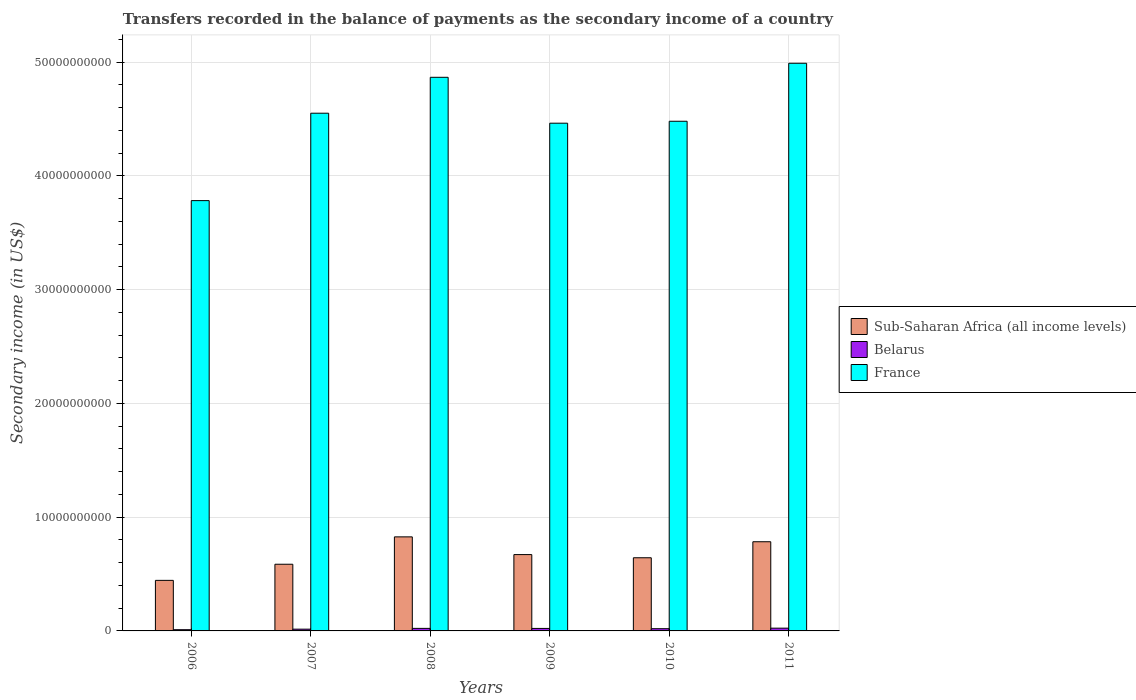How many different coloured bars are there?
Ensure brevity in your answer.  3. Are the number of bars per tick equal to the number of legend labels?
Provide a succinct answer. Yes. Are the number of bars on each tick of the X-axis equal?
Provide a succinct answer. Yes. How many bars are there on the 4th tick from the left?
Ensure brevity in your answer.  3. How many bars are there on the 4th tick from the right?
Give a very brief answer. 3. In how many cases, is the number of bars for a given year not equal to the number of legend labels?
Your answer should be compact. 0. What is the secondary income of in France in 2006?
Keep it short and to the point. 3.78e+1. Across all years, what is the maximum secondary income of in France?
Your answer should be very brief. 4.99e+1. Across all years, what is the minimum secondary income of in France?
Offer a terse response. 3.78e+1. In which year was the secondary income of in Belarus maximum?
Offer a very short reply. 2011. In which year was the secondary income of in Belarus minimum?
Give a very brief answer. 2006. What is the total secondary income of in Belarus in the graph?
Your response must be concise. 1.14e+09. What is the difference between the secondary income of in Belarus in 2007 and that in 2010?
Your response must be concise. -4.09e+07. What is the difference between the secondary income of in Sub-Saharan Africa (all income levels) in 2008 and the secondary income of in France in 2009?
Provide a succinct answer. -3.64e+1. What is the average secondary income of in Sub-Saharan Africa (all income levels) per year?
Your answer should be compact. 6.59e+09. In the year 2009, what is the difference between the secondary income of in France and secondary income of in Sub-Saharan Africa (all income levels)?
Your response must be concise. 3.79e+1. What is the ratio of the secondary income of in Belarus in 2006 to that in 2011?
Your answer should be compact. 0.45. Is the difference between the secondary income of in France in 2006 and 2011 greater than the difference between the secondary income of in Sub-Saharan Africa (all income levels) in 2006 and 2011?
Your answer should be compact. No. What is the difference between the highest and the second highest secondary income of in Sub-Saharan Africa (all income levels)?
Your answer should be very brief. 4.28e+08. What is the difference between the highest and the lowest secondary income of in Belarus?
Provide a short and direct response. 1.35e+08. In how many years, is the secondary income of in France greater than the average secondary income of in France taken over all years?
Keep it short and to the point. 3. Is the sum of the secondary income of in France in 2009 and 2010 greater than the maximum secondary income of in Sub-Saharan Africa (all income levels) across all years?
Give a very brief answer. Yes. What does the 3rd bar from the left in 2006 represents?
Make the answer very short. France. What does the 3rd bar from the right in 2011 represents?
Provide a succinct answer. Sub-Saharan Africa (all income levels). Is it the case that in every year, the sum of the secondary income of in France and secondary income of in Belarus is greater than the secondary income of in Sub-Saharan Africa (all income levels)?
Offer a terse response. Yes. Are all the bars in the graph horizontal?
Provide a short and direct response. No. How many years are there in the graph?
Offer a very short reply. 6. What is the difference between two consecutive major ticks on the Y-axis?
Make the answer very short. 1.00e+1. Are the values on the major ticks of Y-axis written in scientific E-notation?
Keep it short and to the point. No. Does the graph contain grids?
Your answer should be very brief. Yes. How are the legend labels stacked?
Your answer should be very brief. Vertical. What is the title of the graph?
Provide a short and direct response. Transfers recorded in the balance of payments as the secondary income of a country. What is the label or title of the Y-axis?
Give a very brief answer. Secondary income (in US$). What is the Secondary income (in US$) in Sub-Saharan Africa (all income levels) in 2006?
Offer a terse response. 4.45e+09. What is the Secondary income (in US$) in Belarus in 2006?
Ensure brevity in your answer.  1.08e+08. What is the Secondary income (in US$) of France in 2006?
Give a very brief answer. 3.78e+1. What is the Secondary income (in US$) of Sub-Saharan Africa (all income levels) in 2007?
Give a very brief answer. 5.86e+09. What is the Secondary income (in US$) of Belarus in 2007?
Keep it short and to the point. 1.55e+08. What is the Secondary income (in US$) in France in 2007?
Make the answer very short. 4.55e+1. What is the Secondary income (in US$) in Sub-Saharan Africa (all income levels) in 2008?
Provide a short and direct response. 8.27e+09. What is the Secondary income (in US$) of Belarus in 2008?
Make the answer very short. 2.23e+08. What is the Secondary income (in US$) of France in 2008?
Offer a very short reply. 4.87e+1. What is the Secondary income (in US$) of Sub-Saharan Africa (all income levels) in 2009?
Keep it short and to the point. 6.71e+09. What is the Secondary income (in US$) in Belarus in 2009?
Your answer should be compact. 2.20e+08. What is the Secondary income (in US$) of France in 2009?
Keep it short and to the point. 4.46e+1. What is the Secondary income (in US$) of Sub-Saharan Africa (all income levels) in 2010?
Your response must be concise. 6.43e+09. What is the Secondary income (in US$) in Belarus in 2010?
Offer a terse response. 1.96e+08. What is the Secondary income (in US$) of France in 2010?
Keep it short and to the point. 4.48e+1. What is the Secondary income (in US$) of Sub-Saharan Africa (all income levels) in 2011?
Offer a very short reply. 7.84e+09. What is the Secondary income (in US$) of Belarus in 2011?
Make the answer very short. 2.43e+08. What is the Secondary income (in US$) of France in 2011?
Your answer should be very brief. 4.99e+1. Across all years, what is the maximum Secondary income (in US$) of Sub-Saharan Africa (all income levels)?
Keep it short and to the point. 8.27e+09. Across all years, what is the maximum Secondary income (in US$) of Belarus?
Your response must be concise. 2.43e+08. Across all years, what is the maximum Secondary income (in US$) of France?
Your answer should be compact. 4.99e+1. Across all years, what is the minimum Secondary income (in US$) in Sub-Saharan Africa (all income levels)?
Provide a succinct answer. 4.45e+09. Across all years, what is the minimum Secondary income (in US$) of Belarus?
Your response must be concise. 1.08e+08. Across all years, what is the minimum Secondary income (in US$) in France?
Offer a terse response. 3.78e+1. What is the total Secondary income (in US$) in Sub-Saharan Africa (all income levels) in the graph?
Your answer should be very brief. 3.96e+1. What is the total Secondary income (in US$) in Belarus in the graph?
Keep it short and to the point. 1.14e+09. What is the total Secondary income (in US$) of France in the graph?
Keep it short and to the point. 2.71e+11. What is the difference between the Secondary income (in US$) of Sub-Saharan Africa (all income levels) in 2006 and that in 2007?
Offer a very short reply. -1.42e+09. What is the difference between the Secondary income (in US$) of Belarus in 2006 and that in 2007?
Give a very brief answer. -4.69e+07. What is the difference between the Secondary income (in US$) in France in 2006 and that in 2007?
Give a very brief answer. -7.69e+09. What is the difference between the Secondary income (in US$) in Sub-Saharan Africa (all income levels) in 2006 and that in 2008?
Provide a succinct answer. -3.82e+09. What is the difference between the Secondary income (in US$) of Belarus in 2006 and that in 2008?
Give a very brief answer. -1.14e+08. What is the difference between the Secondary income (in US$) in France in 2006 and that in 2008?
Offer a terse response. -1.08e+1. What is the difference between the Secondary income (in US$) in Sub-Saharan Africa (all income levels) in 2006 and that in 2009?
Offer a terse response. -2.27e+09. What is the difference between the Secondary income (in US$) of Belarus in 2006 and that in 2009?
Provide a succinct answer. -1.12e+08. What is the difference between the Secondary income (in US$) in France in 2006 and that in 2009?
Give a very brief answer. -6.81e+09. What is the difference between the Secondary income (in US$) in Sub-Saharan Africa (all income levels) in 2006 and that in 2010?
Make the answer very short. -1.99e+09. What is the difference between the Secondary income (in US$) of Belarus in 2006 and that in 2010?
Give a very brief answer. -8.78e+07. What is the difference between the Secondary income (in US$) of France in 2006 and that in 2010?
Give a very brief answer. -6.98e+09. What is the difference between the Secondary income (in US$) of Sub-Saharan Africa (all income levels) in 2006 and that in 2011?
Make the answer very short. -3.40e+09. What is the difference between the Secondary income (in US$) of Belarus in 2006 and that in 2011?
Make the answer very short. -1.35e+08. What is the difference between the Secondary income (in US$) in France in 2006 and that in 2011?
Keep it short and to the point. -1.21e+1. What is the difference between the Secondary income (in US$) of Sub-Saharan Africa (all income levels) in 2007 and that in 2008?
Give a very brief answer. -2.41e+09. What is the difference between the Secondary income (in US$) of Belarus in 2007 and that in 2008?
Offer a very short reply. -6.76e+07. What is the difference between the Secondary income (in US$) in France in 2007 and that in 2008?
Make the answer very short. -3.16e+09. What is the difference between the Secondary income (in US$) in Sub-Saharan Africa (all income levels) in 2007 and that in 2009?
Offer a very short reply. -8.49e+08. What is the difference between the Secondary income (in US$) of Belarus in 2007 and that in 2009?
Make the answer very short. -6.47e+07. What is the difference between the Secondary income (in US$) in France in 2007 and that in 2009?
Provide a succinct answer. 8.78e+08. What is the difference between the Secondary income (in US$) of Sub-Saharan Africa (all income levels) in 2007 and that in 2010?
Provide a short and direct response. -5.71e+08. What is the difference between the Secondary income (in US$) of Belarus in 2007 and that in 2010?
Give a very brief answer. -4.09e+07. What is the difference between the Secondary income (in US$) in France in 2007 and that in 2010?
Your answer should be very brief. 7.08e+08. What is the difference between the Secondary income (in US$) in Sub-Saharan Africa (all income levels) in 2007 and that in 2011?
Offer a terse response. -1.98e+09. What is the difference between the Secondary income (in US$) in Belarus in 2007 and that in 2011?
Give a very brief answer. -8.79e+07. What is the difference between the Secondary income (in US$) of France in 2007 and that in 2011?
Your answer should be compact. -4.39e+09. What is the difference between the Secondary income (in US$) of Sub-Saharan Africa (all income levels) in 2008 and that in 2009?
Your answer should be compact. 1.56e+09. What is the difference between the Secondary income (in US$) of Belarus in 2008 and that in 2009?
Your response must be concise. 2.90e+06. What is the difference between the Secondary income (in US$) in France in 2008 and that in 2009?
Provide a short and direct response. 4.04e+09. What is the difference between the Secondary income (in US$) in Sub-Saharan Africa (all income levels) in 2008 and that in 2010?
Provide a succinct answer. 1.84e+09. What is the difference between the Secondary income (in US$) in Belarus in 2008 and that in 2010?
Offer a very short reply. 2.67e+07. What is the difference between the Secondary income (in US$) in France in 2008 and that in 2010?
Your response must be concise. 3.86e+09. What is the difference between the Secondary income (in US$) of Sub-Saharan Africa (all income levels) in 2008 and that in 2011?
Make the answer very short. 4.28e+08. What is the difference between the Secondary income (in US$) in Belarus in 2008 and that in 2011?
Your response must be concise. -2.03e+07. What is the difference between the Secondary income (in US$) of France in 2008 and that in 2011?
Your answer should be compact. -1.23e+09. What is the difference between the Secondary income (in US$) in Sub-Saharan Africa (all income levels) in 2009 and that in 2010?
Make the answer very short. 2.78e+08. What is the difference between the Secondary income (in US$) of Belarus in 2009 and that in 2010?
Give a very brief answer. 2.38e+07. What is the difference between the Secondary income (in US$) of France in 2009 and that in 2010?
Keep it short and to the point. -1.71e+08. What is the difference between the Secondary income (in US$) in Sub-Saharan Africa (all income levels) in 2009 and that in 2011?
Make the answer very short. -1.13e+09. What is the difference between the Secondary income (in US$) in Belarus in 2009 and that in 2011?
Make the answer very short. -2.32e+07. What is the difference between the Secondary income (in US$) of France in 2009 and that in 2011?
Ensure brevity in your answer.  -5.27e+09. What is the difference between the Secondary income (in US$) in Sub-Saharan Africa (all income levels) in 2010 and that in 2011?
Provide a short and direct response. -1.41e+09. What is the difference between the Secondary income (in US$) of Belarus in 2010 and that in 2011?
Your answer should be very brief. -4.70e+07. What is the difference between the Secondary income (in US$) in France in 2010 and that in 2011?
Your response must be concise. -5.10e+09. What is the difference between the Secondary income (in US$) in Sub-Saharan Africa (all income levels) in 2006 and the Secondary income (in US$) in Belarus in 2007?
Provide a succinct answer. 4.29e+09. What is the difference between the Secondary income (in US$) in Sub-Saharan Africa (all income levels) in 2006 and the Secondary income (in US$) in France in 2007?
Your answer should be compact. -4.11e+1. What is the difference between the Secondary income (in US$) in Belarus in 2006 and the Secondary income (in US$) in France in 2007?
Your answer should be compact. -4.54e+1. What is the difference between the Secondary income (in US$) of Sub-Saharan Africa (all income levels) in 2006 and the Secondary income (in US$) of Belarus in 2008?
Offer a terse response. 4.22e+09. What is the difference between the Secondary income (in US$) in Sub-Saharan Africa (all income levels) in 2006 and the Secondary income (in US$) in France in 2008?
Give a very brief answer. -4.42e+1. What is the difference between the Secondary income (in US$) of Belarus in 2006 and the Secondary income (in US$) of France in 2008?
Provide a short and direct response. -4.86e+1. What is the difference between the Secondary income (in US$) of Sub-Saharan Africa (all income levels) in 2006 and the Secondary income (in US$) of Belarus in 2009?
Offer a very short reply. 4.23e+09. What is the difference between the Secondary income (in US$) in Sub-Saharan Africa (all income levels) in 2006 and the Secondary income (in US$) in France in 2009?
Your answer should be compact. -4.02e+1. What is the difference between the Secondary income (in US$) in Belarus in 2006 and the Secondary income (in US$) in France in 2009?
Ensure brevity in your answer.  -4.45e+1. What is the difference between the Secondary income (in US$) of Sub-Saharan Africa (all income levels) in 2006 and the Secondary income (in US$) of Belarus in 2010?
Make the answer very short. 4.25e+09. What is the difference between the Secondary income (in US$) of Sub-Saharan Africa (all income levels) in 2006 and the Secondary income (in US$) of France in 2010?
Your answer should be compact. -4.04e+1. What is the difference between the Secondary income (in US$) of Belarus in 2006 and the Secondary income (in US$) of France in 2010?
Give a very brief answer. -4.47e+1. What is the difference between the Secondary income (in US$) of Sub-Saharan Africa (all income levels) in 2006 and the Secondary income (in US$) of Belarus in 2011?
Offer a terse response. 4.20e+09. What is the difference between the Secondary income (in US$) of Sub-Saharan Africa (all income levels) in 2006 and the Secondary income (in US$) of France in 2011?
Make the answer very short. -4.55e+1. What is the difference between the Secondary income (in US$) in Belarus in 2006 and the Secondary income (in US$) in France in 2011?
Provide a succinct answer. -4.98e+1. What is the difference between the Secondary income (in US$) in Sub-Saharan Africa (all income levels) in 2007 and the Secondary income (in US$) in Belarus in 2008?
Give a very brief answer. 5.64e+09. What is the difference between the Secondary income (in US$) in Sub-Saharan Africa (all income levels) in 2007 and the Secondary income (in US$) in France in 2008?
Provide a short and direct response. -4.28e+1. What is the difference between the Secondary income (in US$) of Belarus in 2007 and the Secondary income (in US$) of France in 2008?
Give a very brief answer. -4.85e+1. What is the difference between the Secondary income (in US$) in Sub-Saharan Africa (all income levels) in 2007 and the Secondary income (in US$) in Belarus in 2009?
Offer a very short reply. 5.64e+09. What is the difference between the Secondary income (in US$) of Sub-Saharan Africa (all income levels) in 2007 and the Secondary income (in US$) of France in 2009?
Your answer should be very brief. -3.88e+1. What is the difference between the Secondary income (in US$) of Belarus in 2007 and the Secondary income (in US$) of France in 2009?
Offer a terse response. -4.45e+1. What is the difference between the Secondary income (in US$) of Sub-Saharan Africa (all income levels) in 2007 and the Secondary income (in US$) of Belarus in 2010?
Your response must be concise. 5.67e+09. What is the difference between the Secondary income (in US$) in Sub-Saharan Africa (all income levels) in 2007 and the Secondary income (in US$) in France in 2010?
Provide a succinct answer. -3.89e+1. What is the difference between the Secondary income (in US$) of Belarus in 2007 and the Secondary income (in US$) of France in 2010?
Provide a short and direct response. -4.47e+1. What is the difference between the Secondary income (in US$) of Sub-Saharan Africa (all income levels) in 2007 and the Secondary income (in US$) of Belarus in 2011?
Offer a very short reply. 5.62e+09. What is the difference between the Secondary income (in US$) of Sub-Saharan Africa (all income levels) in 2007 and the Secondary income (in US$) of France in 2011?
Ensure brevity in your answer.  -4.40e+1. What is the difference between the Secondary income (in US$) in Belarus in 2007 and the Secondary income (in US$) in France in 2011?
Offer a terse response. -4.98e+1. What is the difference between the Secondary income (in US$) of Sub-Saharan Africa (all income levels) in 2008 and the Secondary income (in US$) of Belarus in 2009?
Your answer should be very brief. 8.05e+09. What is the difference between the Secondary income (in US$) in Sub-Saharan Africa (all income levels) in 2008 and the Secondary income (in US$) in France in 2009?
Your response must be concise. -3.64e+1. What is the difference between the Secondary income (in US$) of Belarus in 2008 and the Secondary income (in US$) of France in 2009?
Offer a terse response. -4.44e+1. What is the difference between the Secondary income (in US$) in Sub-Saharan Africa (all income levels) in 2008 and the Secondary income (in US$) in Belarus in 2010?
Offer a very short reply. 8.07e+09. What is the difference between the Secondary income (in US$) of Sub-Saharan Africa (all income levels) in 2008 and the Secondary income (in US$) of France in 2010?
Provide a succinct answer. -3.65e+1. What is the difference between the Secondary income (in US$) of Belarus in 2008 and the Secondary income (in US$) of France in 2010?
Offer a terse response. -4.46e+1. What is the difference between the Secondary income (in US$) in Sub-Saharan Africa (all income levels) in 2008 and the Secondary income (in US$) in Belarus in 2011?
Provide a succinct answer. 8.03e+09. What is the difference between the Secondary income (in US$) in Sub-Saharan Africa (all income levels) in 2008 and the Secondary income (in US$) in France in 2011?
Give a very brief answer. -4.16e+1. What is the difference between the Secondary income (in US$) of Belarus in 2008 and the Secondary income (in US$) of France in 2011?
Keep it short and to the point. -4.97e+1. What is the difference between the Secondary income (in US$) of Sub-Saharan Africa (all income levels) in 2009 and the Secondary income (in US$) of Belarus in 2010?
Offer a terse response. 6.52e+09. What is the difference between the Secondary income (in US$) in Sub-Saharan Africa (all income levels) in 2009 and the Secondary income (in US$) in France in 2010?
Provide a succinct answer. -3.81e+1. What is the difference between the Secondary income (in US$) of Belarus in 2009 and the Secondary income (in US$) of France in 2010?
Provide a succinct answer. -4.46e+1. What is the difference between the Secondary income (in US$) in Sub-Saharan Africa (all income levels) in 2009 and the Secondary income (in US$) in Belarus in 2011?
Offer a terse response. 6.47e+09. What is the difference between the Secondary income (in US$) in Sub-Saharan Africa (all income levels) in 2009 and the Secondary income (in US$) in France in 2011?
Provide a succinct answer. -4.32e+1. What is the difference between the Secondary income (in US$) in Belarus in 2009 and the Secondary income (in US$) in France in 2011?
Your answer should be compact. -4.97e+1. What is the difference between the Secondary income (in US$) in Sub-Saharan Africa (all income levels) in 2010 and the Secondary income (in US$) in Belarus in 2011?
Your answer should be very brief. 6.19e+09. What is the difference between the Secondary income (in US$) of Sub-Saharan Africa (all income levels) in 2010 and the Secondary income (in US$) of France in 2011?
Offer a terse response. -4.35e+1. What is the difference between the Secondary income (in US$) of Belarus in 2010 and the Secondary income (in US$) of France in 2011?
Your answer should be very brief. -4.97e+1. What is the average Secondary income (in US$) in Sub-Saharan Africa (all income levels) per year?
Your answer should be compact. 6.59e+09. What is the average Secondary income (in US$) of Belarus per year?
Your answer should be compact. 1.91e+08. What is the average Secondary income (in US$) of France per year?
Ensure brevity in your answer.  4.52e+1. In the year 2006, what is the difference between the Secondary income (in US$) in Sub-Saharan Africa (all income levels) and Secondary income (in US$) in Belarus?
Give a very brief answer. 4.34e+09. In the year 2006, what is the difference between the Secondary income (in US$) of Sub-Saharan Africa (all income levels) and Secondary income (in US$) of France?
Your answer should be compact. -3.34e+1. In the year 2006, what is the difference between the Secondary income (in US$) in Belarus and Secondary income (in US$) in France?
Make the answer very short. -3.77e+1. In the year 2007, what is the difference between the Secondary income (in US$) in Sub-Saharan Africa (all income levels) and Secondary income (in US$) in Belarus?
Provide a succinct answer. 5.71e+09. In the year 2007, what is the difference between the Secondary income (in US$) in Sub-Saharan Africa (all income levels) and Secondary income (in US$) in France?
Your response must be concise. -3.97e+1. In the year 2007, what is the difference between the Secondary income (in US$) of Belarus and Secondary income (in US$) of France?
Provide a short and direct response. -4.54e+1. In the year 2008, what is the difference between the Secondary income (in US$) in Sub-Saharan Africa (all income levels) and Secondary income (in US$) in Belarus?
Keep it short and to the point. 8.05e+09. In the year 2008, what is the difference between the Secondary income (in US$) of Sub-Saharan Africa (all income levels) and Secondary income (in US$) of France?
Ensure brevity in your answer.  -4.04e+1. In the year 2008, what is the difference between the Secondary income (in US$) of Belarus and Secondary income (in US$) of France?
Offer a very short reply. -4.85e+1. In the year 2009, what is the difference between the Secondary income (in US$) in Sub-Saharan Africa (all income levels) and Secondary income (in US$) in Belarus?
Give a very brief answer. 6.49e+09. In the year 2009, what is the difference between the Secondary income (in US$) in Sub-Saharan Africa (all income levels) and Secondary income (in US$) in France?
Your answer should be very brief. -3.79e+1. In the year 2009, what is the difference between the Secondary income (in US$) of Belarus and Secondary income (in US$) of France?
Your answer should be compact. -4.44e+1. In the year 2010, what is the difference between the Secondary income (in US$) of Sub-Saharan Africa (all income levels) and Secondary income (in US$) of Belarus?
Your answer should be very brief. 6.24e+09. In the year 2010, what is the difference between the Secondary income (in US$) in Sub-Saharan Africa (all income levels) and Secondary income (in US$) in France?
Your response must be concise. -3.84e+1. In the year 2010, what is the difference between the Secondary income (in US$) of Belarus and Secondary income (in US$) of France?
Your answer should be very brief. -4.46e+1. In the year 2011, what is the difference between the Secondary income (in US$) of Sub-Saharan Africa (all income levels) and Secondary income (in US$) of Belarus?
Offer a terse response. 7.60e+09. In the year 2011, what is the difference between the Secondary income (in US$) in Sub-Saharan Africa (all income levels) and Secondary income (in US$) in France?
Your answer should be compact. -4.21e+1. In the year 2011, what is the difference between the Secondary income (in US$) in Belarus and Secondary income (in US$) in France?
Keep it short and to the point. -4.97e+1. What is the ratio of the Secondary income (in US$) of Sub-Saharan Africa (all income levels) in 2006 to that in 2007?
Ensure brevity in your answer.  0.76. What is the ratio of the Secondary income (in US$) of Belarus in 2006 to that in 2007?
Offer a terse response. 0.7. What is the ratio of the Secondary income (in US$) in France in 2006 to that in 2007?
Provide a short and direct response. 0.83. What is the ratio of the Secondary income (in US$) of Sub-Saharan Africa (all income levels) in 2006 to that in 2008?
Keep it short and to the point. 0.54. What is the ratio of the Secondary income (in US$) of Belarus in 2006 to that in 2008?
Provide a succinct answer. 0.49. What is the ratio of the Secondary income (in US$) of France in 2006 to that in 2008?
Your answer should be compact. 0.78. What is the ratio of the Secondary income (in US$) in Sub-Saharan Africa (all income levels) in 2006 to that in 2009?
Provide a succinct answer. 0.66. What is the ratio of the Secondary income (in US$) in Belarus in 2006 to that in 2009?
Provide a short and direct response. 0.49. What is the ratio of the Secondary income (in US$) in France in 2006 to that in 2009?
Make the answer very short. 0.85. What is the ratio of the Secondary income (in US$) in Sub-Saharan Africa (all income levels) in 2006 to that in 2010?
Make the answer very short. 0.69. What is the ratio of the Secondary income (in US$) in Belarus in 2006 to that in 2010?
Offer a terse response. 0.55. What is the ratio of the Secondary income (in US$) in France in 2006 to that in 2010?
Keep it short and to the point. 0.84. What is the ratio of the Secondary income (in US$) of Sub-Saharan Africa (all income levels) in 2006 to that in 2011?
Give a very brief answer. 0.57. What is the ratio of the Secondary income (in US$) in Belarus in 2006 to that in 2011?
Provide a short and direct response. 0.45. What is the ratio of the Secondary income (in US$) in France in 2006 to that in 2011?
Your answer should be compact. 0.76. What is the ratio of the Secondary income (in US$) in Sub-Saharan Africa (all income levels) in 2007 to that in 2008?
Ensure brevity in your answer.  0.71. What is the ratio of the Secondary income (in US$) of Belarus in 2007 to that in 2008?
Make the answer very short. 0.7. What is the ratio of the Secondary income (in US$) in France in 2007 to that in 2008?
Offer a very short reply. 0.94. What is the ratio of the Secondary income (in US$) of Sub-Saharan Africa (all income levels) in 2007 to that in 2009?
Your response must be concise. 0.87. What is the ratio of the Secondary income (in US$) in Belarus in 2007 to that in 2009?
Offer a terse response. 0.71. What is the ratio of the Secondary income (in US$) of France in 2007 to that in 2009?
Provide a short and direct response. 1.02. What is the ratio of the Secondary income (in US$) of Sub-Saharan Africa (all income levels) in 2007 to that in 2010?
Provide a succinct answer. 0.91. What is the ratio of the Secondary income (in US$) of Belarus in 2007 to that in 2010?
Keep it short and to the point. 0.79. What is the ratio of the Secondary income (in US$) of France in 2007 to that in 2010?
Your response must be concise. 1.02. What is the ratio of the Secondary income (in US$) in Sub-Saharan Africa (all income levels) in 2007 to that in 2011?
Offer a very short reply. 0.75. What is the ratio of the Secondary income (in US$) of Belarus in 2007 to that in 2011?
Your answer should be compact. 0.64. What is the ratio of the Secondary income (in US$) in France in 2007 to that in 2011?
Provide a succinct answer. 0.91. What is the ratio of the Secondary income (in US$) in Sub-Saharan Africa (all income levels) in 2008 to that in 2009?
Give a very brief answer. 1.23. What is the ratio of the Secondary income (in US$) of Belarus in 2008 to that in 2009?
Your response must be concise. 1.01. What is the ratio of the Secondary income (in US$) of France in 2008 to that in 2009?
Make the answer very short. 1.09. What is the ratio of the Secondary income (in US$) of Sub-Saharan Africa (all income levels) in 2008 to that in 2010?
Provide a succinct answer. 1.29. What is the ratio of the Secondary income (in US$) in Belarus in 2008 to that in 2010?
Your answer should be compact. 1.14. What is the ratio of the Secondary income (in US$) of France in 2008 to that in 2010?
Offer a very short reply. 1.09. What is the ratio of the Secondary income (in US$) of Sub-Saharan Africa (all income levels) in 2008 to that in 2011?
Provide a short and direct response. 1.05. What is the ratio of the Secondary income (in US$) of Belarus in 2008 to that in 2011?
Your answer should be very brief. 0.92. What is the ratio of the Secondary income (in US$) of France in 2008 to that in 2011?
Ensure brevity in your answer.  0.98. What is the ratio of the Secondary income (in US$) in Sub-Saharan Africa (all income levels) in 2009 to that in 2010?
Offer a very short reply. 1.04. What is the ratio of the Secondary income (in US$) of Belarus in 2009 to that in 2010?
Your answer should be very brief. 1.12. What is the ratio of the Secondary income (in US$) of Sub-Saharan Africa (all income levels) in 2009 to that in 2011?
Your answer should be very brief. 0.86. What is the ratio of the Secondary income (in US$) of Belarus in 2009 to that in 2011?
Provide a succinct answer. 0.9. What is the ratio of the Secondary income (in US$) of France in 2009 to that in 2011?
Your answer should be very brief. 0.89. What is the ratio of the Secondary income (in US$) in Sub-Saharan Africa (all income levels) in 2010 to that in 2011?
Ensure brevity in your answer.  0.82. What is the ratio of the Secondary income (in US$) of Belarus in 2010 to that in 2011?
Keep it short and to the point. 0.81. What is the ratio of the Secondary income (in US$) in France in 2010 to that in 2011?
Give a very brief answer. 0.9. What is the difference between the highest and the second highest Secondary income (in US$) of Sub-Saharan Africa (all income levels)?
Offer a terse response. 4.28e+08. What is the difference between the highest and the second highest Secondary income (in US$) in Belarus?
Offer a very short reply. 2.03e+07. What is the difference between the highest and the second highest Secondary income (in US$) of France?
Ensure brevity in your answer.  1.23e+09. What is the difference between the highest and the lowest Secondary income (in US$) in Sub-Saharan Africa (all income levels)?
Provide a succinct answer. 3.82e+09. What is the difference between the highest and the lowest Secondary income (in US$) of Belarus?
Your response must be concise. 1.35e+08. What is the difference between the highest and the lowest Secondary income (in US$) of France?
Your response must be concise. 1.21e+1. 